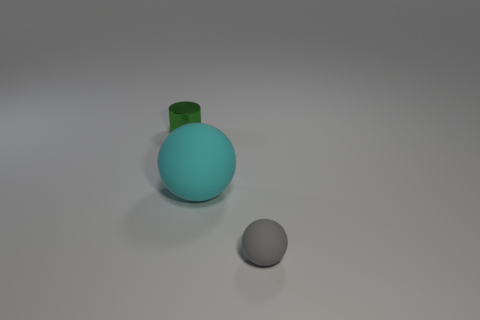Subtract all blue cubes. How many purple cylinders are left? 0 Subtract all big yellow spheres. Subtract all small balls. How many objects are left? 2 Add 3 tiny cylinders. How many tiny cylinders are left? 4 Add 2 tiny gray matte objects. How many tiny gray matte objects exist? 3 Add 1 big cyan cubes. How many objects exist? 4 Subtract 0 gray cylinders. How many objects are left? 3 Subtract all spheres. How many objects are left? 1 Subtract all cyan spheres. Subtract all gray cubes. How many spheres are left? 1 